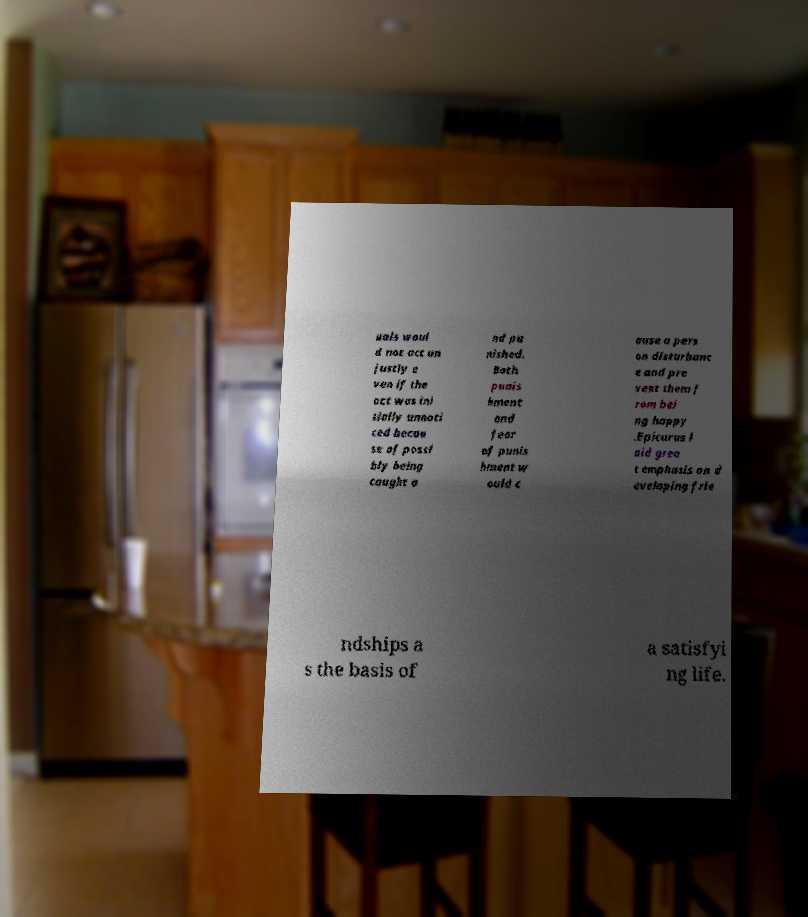There's text embedded in this image that I need extracted. Can you transcribe it verbatim? uals woul d not act un justly e ven if the act was ini tially unnoti ced becau se of possi bly being caught a nd pu nished. Both punis hment and fear of punis hment w ould c ause a pers on disturbanc e and pre vent them f rom bei ng happy .Epicurus l aid grea t emphasis on d eveloping frie ndships a s the basis of a satisfyi ng life. 